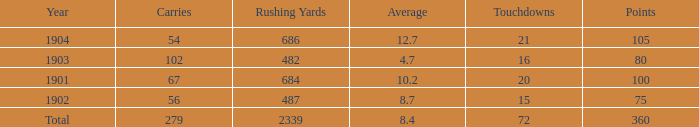What is the average number of carries that have more than 72 touchdowns? None. 